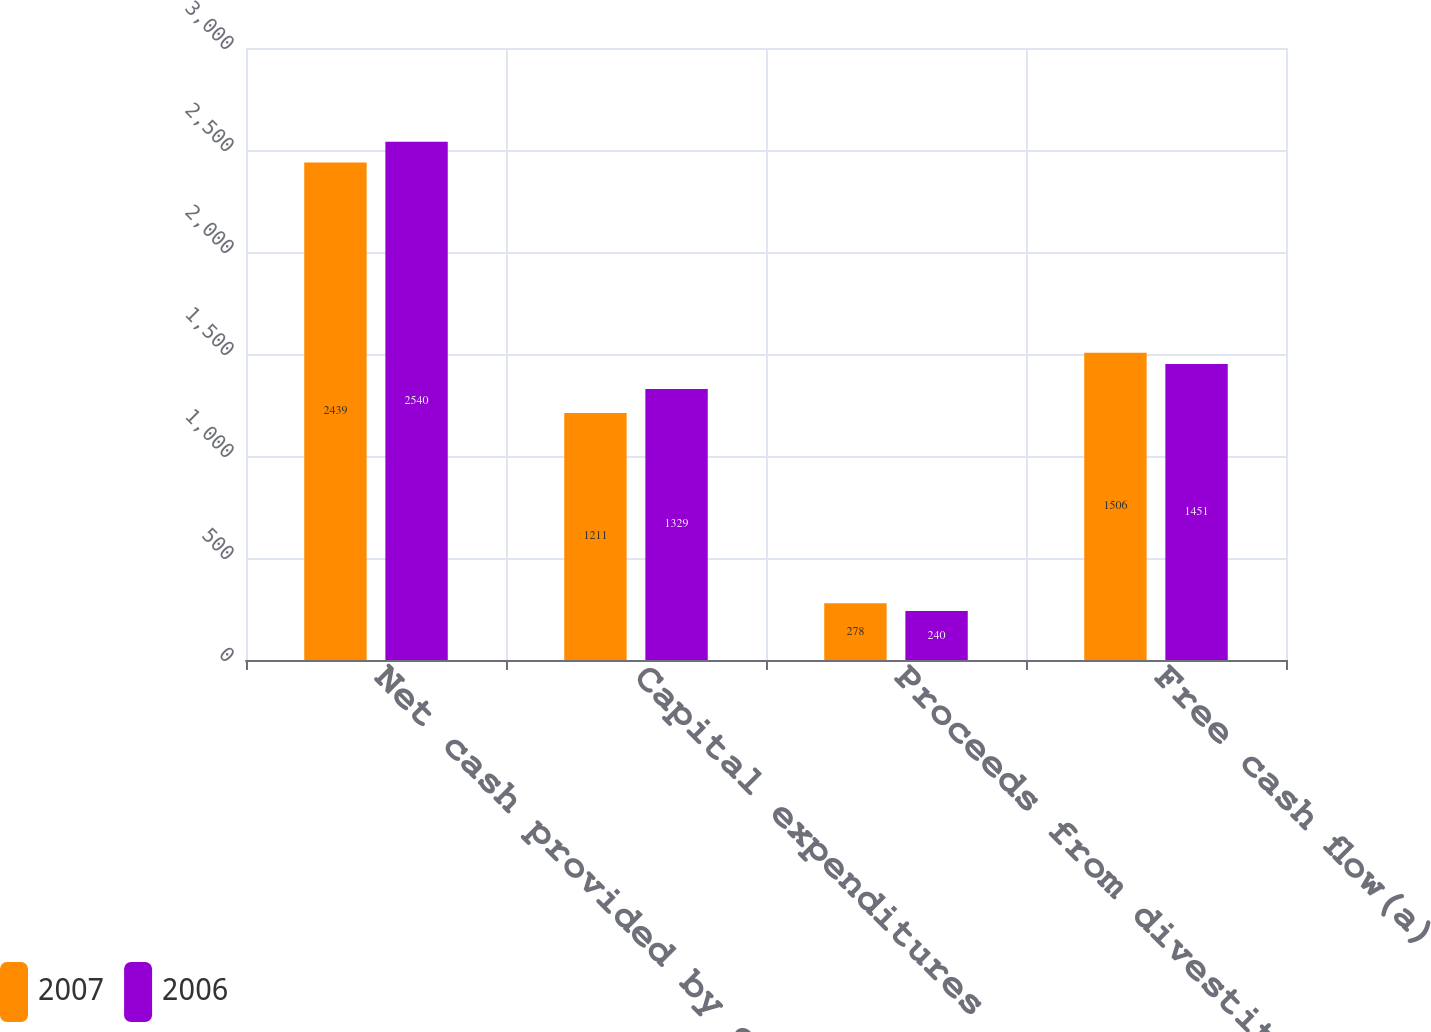Convert chart to OTSL. <chart><loc_0><loc_0><loc_500><loc_500><stacked_bar_chart><ecel><fcel>Net cash provided by operating<fcel>Capital expenditures<fcel>Proceeds from divestitures of<fcel>Free cash flow(a)<nl><fcel>2007<fcel>2439<fcel>1211<fcel>278<fcel>1506<nl><fcel>2006<fcel>2540<fcel>1329<fcel>240<fcel>1451<nl></chart> 